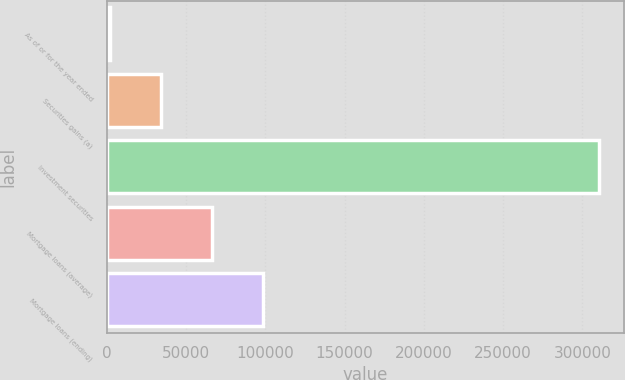Convert chart to OTSL. <chart><loc_0><loc_0><loc_500><loc_500><bar_chart><fcel>As of or for the year ended<fcel>Securities gains (a)<fcel>Investment securities<fcel>Mortgage loans (average)<fcel>Mortgage loans (ending)<nl><fcel>2010<fcel>34176.3<fcel>310801<fcel>66342.6<fcel>98508.9<nl></chart> 